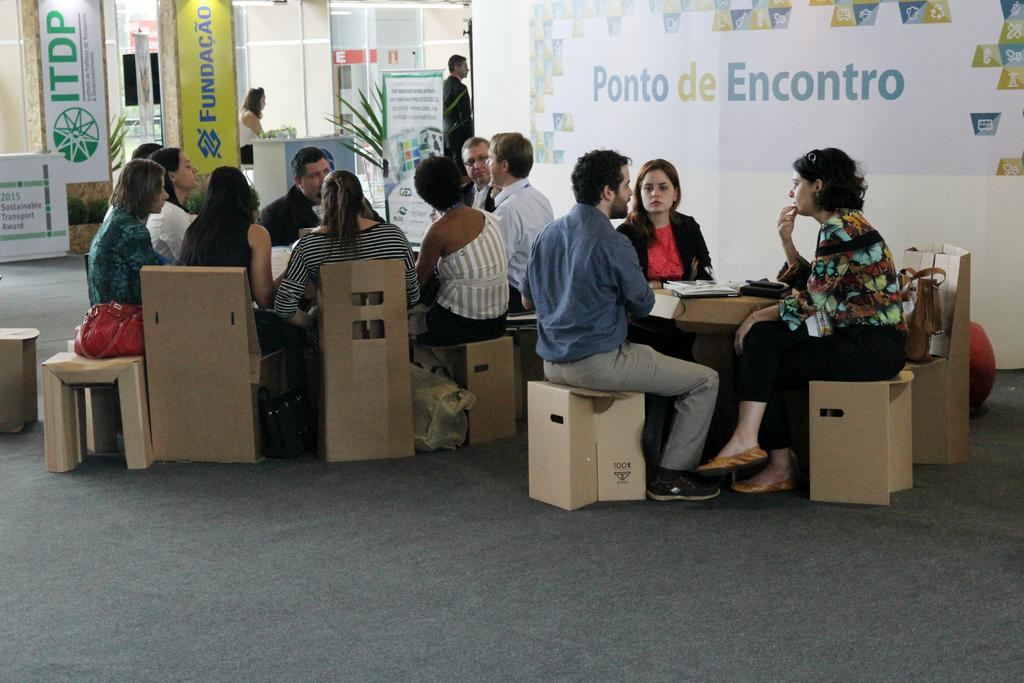What is happening in the image involving the group of people? The people in the image are sitting and discussing. What can be seen in the background of the image? There is a banner in the background of the image, and there are people standing. Can you describe the activity of the people in the background? The people standing in the background are not actively participating in the discussion, but they might be observing or waiting. What type of comfort does the giraffe provide in the image? There is no giraffe present in the image, so it cannot provide any comfort. 